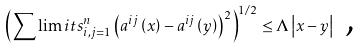<formula> <loc_0><loc_0><loc_500><loc_500>\left ( \sum \lim i t s _ { i , j = 1 } ^ { n } \left ( a ^ { i j } \left ( x \right ) - a ^ { i j } \left ( y \right ) \right ) ^ { 2 } \right ) ^ { 1 / 2 } \leq \Lambda \left | x - y \right | \text { ,}</formula> 